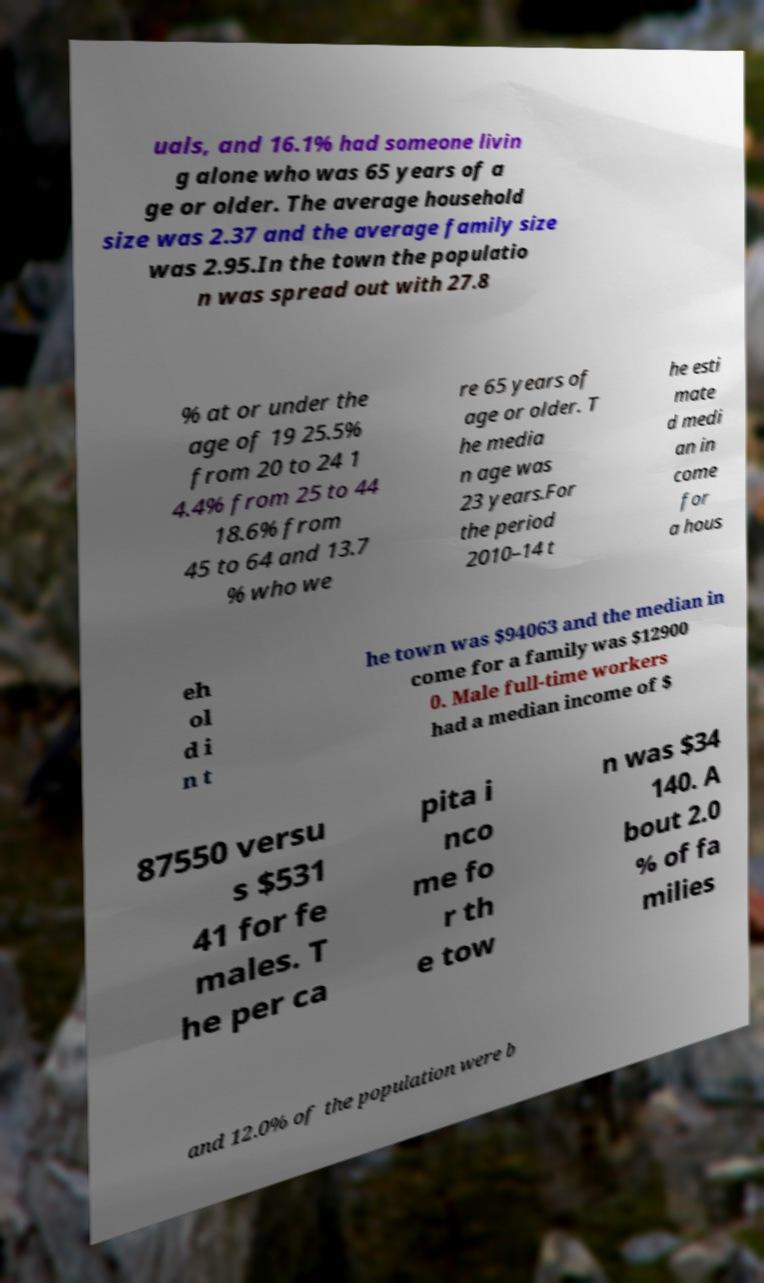Can you accurately transcribe the text from the provided image for me? uals, and 16.1% had someone livin g alone who was 65 years of a ge or older. The average household size was 2.37 and the average family size was 2.95.In the town the populatio n was spread out with 27.8 % at or under the age of 19 25.5% from 20 to 24 1 4.4% from 25 to 44 18.6% from 45 to 64 and 13.7 % who we re 65 years of age or older. T he media n age was 23 years.For the period 2010–14 t he esti mate d medi an in come for a hous eh ol d i n t he town was $94063 and the median in come for a family was $12900 0. Male full-time workers had a median income of $ 87550 versu s $531 41 for fe males. T he per ca pita i nco me fo r th e tow n was $34 140. A bout 2.0 % of fa milies and 12.0% of the population were b 